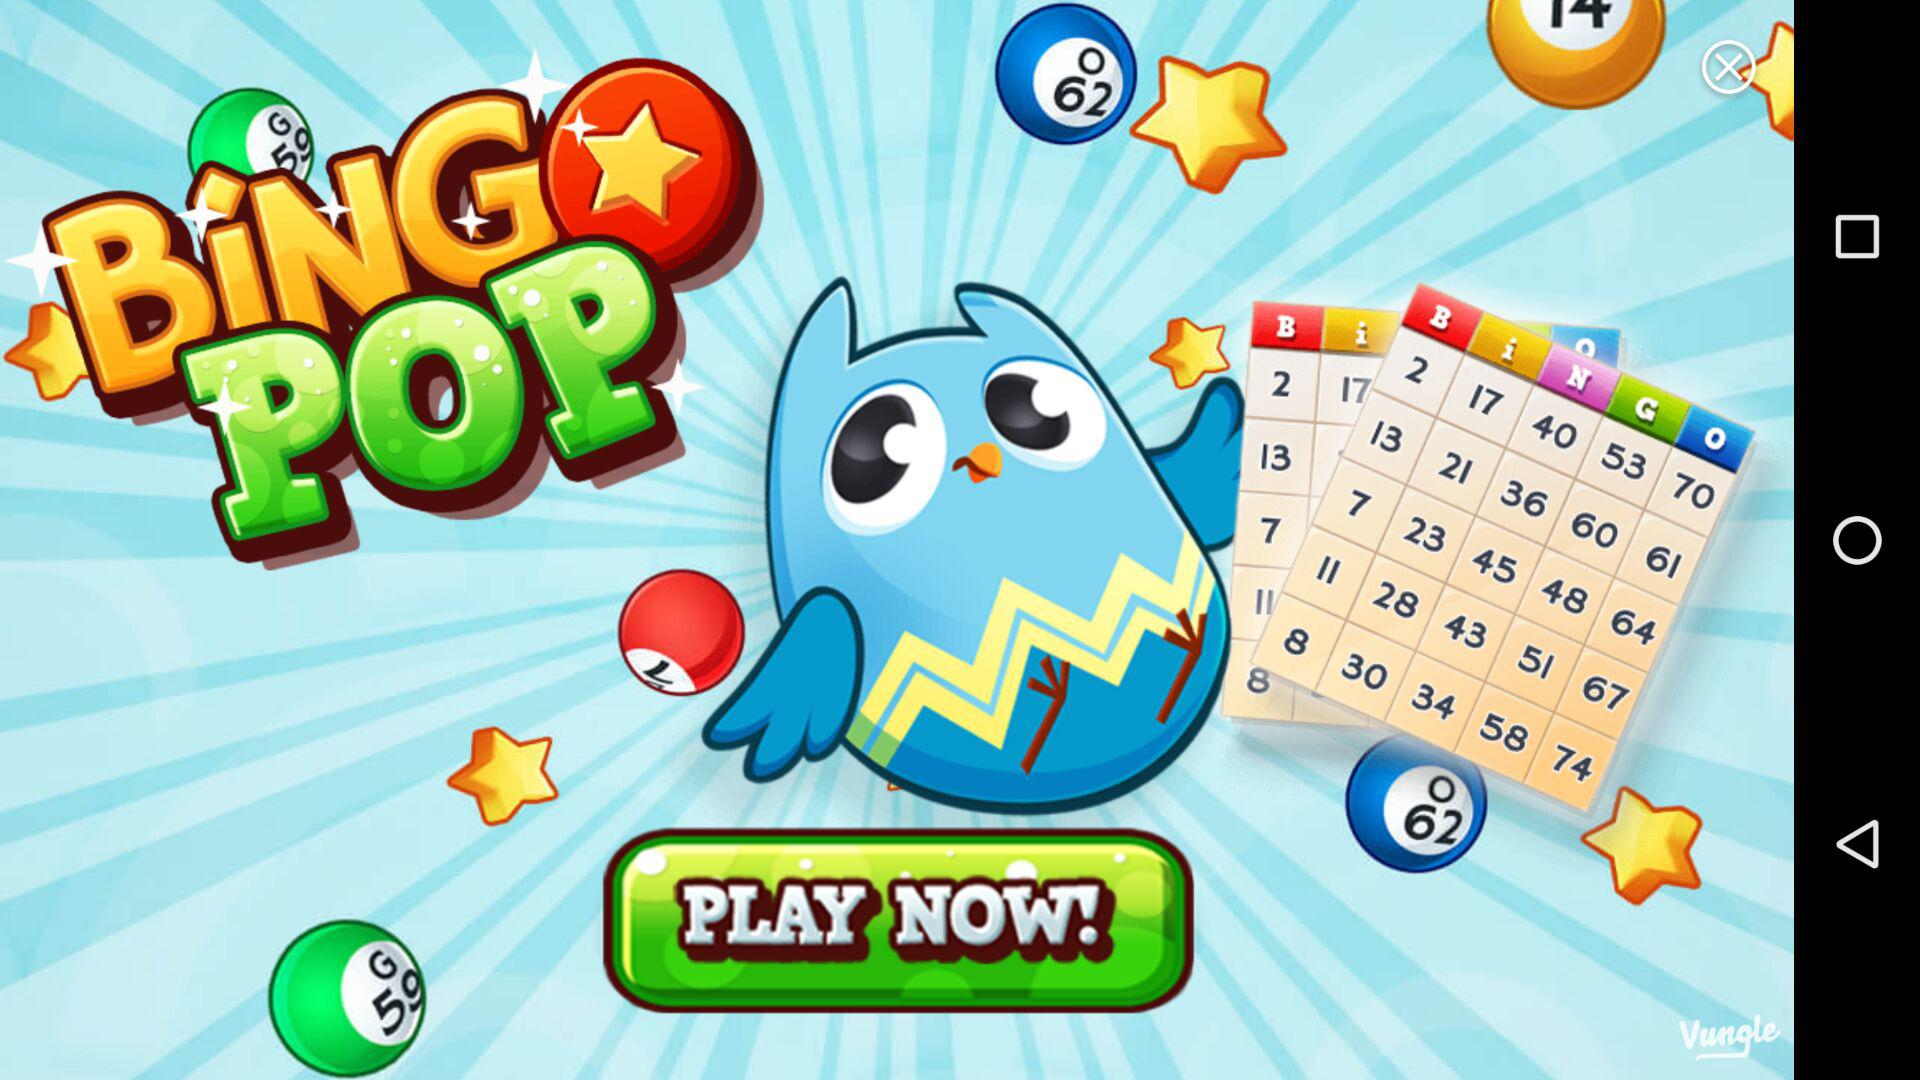Which day does Reward 30 correspond to? Reward 30 corresponds to day 5. 